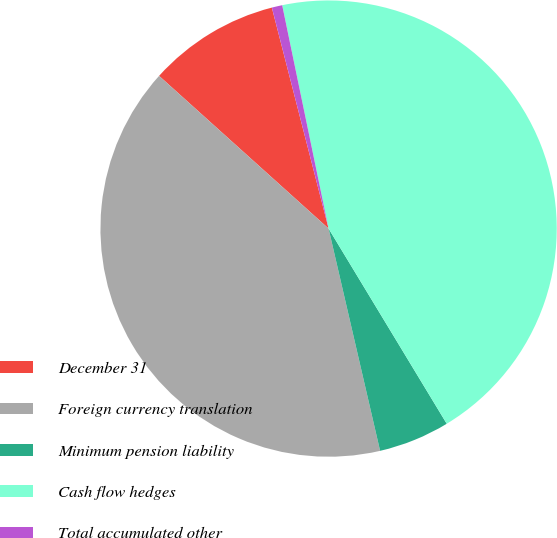Convert chart to OTSL. <chart><loc_0><loc_0><loc_500><loc_500><pie_chart><fcel>December 31<fcel>Foreign currency translation<fcel>Minimum pension liability<fcel>Cash flow hedges<fcel>Total accumulated other<nl><fcel>9.33%<fcel>40.3%<fcel>5.04%<fcel>44.6%<fcel>0.74%<nl></chart> 